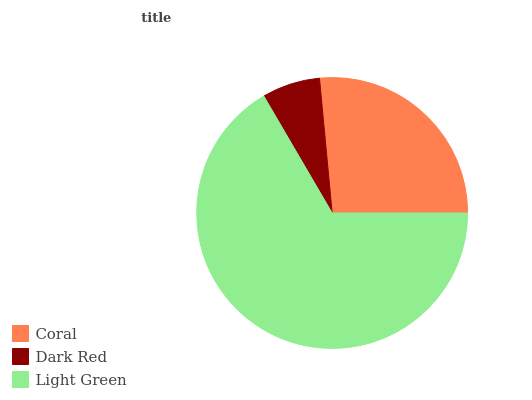Is Dark Red the minimum?
Answer yes or no. Yes. Is Light Green the maximum?
Answer yes or no. Yes. Is Light Green the minimum?
Answer yes or no. No. Is Dark Red the maximum?
Answer yes or no. No. Is Light Green greater than Dark Red?
Answer yes or no. Yes. Is Dark Red less than Light Green?
Answer yes or no. Yes. Is Dark Red greater than Light Green?
Answer yes or no. No. Is Light Green less than Dark Red?
Answer yes or no. No. Is Coral the high median?
Answer yes or no. Yes. Is Coral the low median?
Answer yes or no. Yes. Is Light Green the high median?
Answer yes or no. No. Is Light Green the low median?
Answer yes or no. No. 